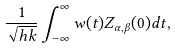<formula> <loc_0><loc_0><loc_500><loc_500>\frac { 1 } { \sqrt { h k } } \int _ { - \infty } ^ { \infty } w ( t ) Z _ { \alpha , \beta } ( 0 ) d t ,</formula> 